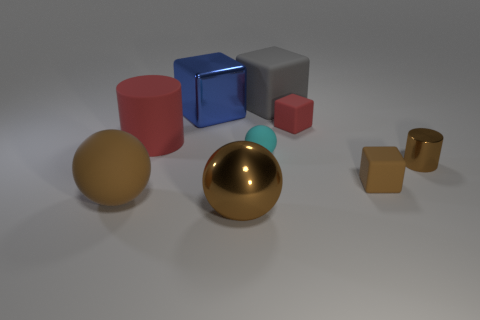There is a sphere that is the same size as the red cube; what is its material?
Ensure brevity in your answer.  Rubber. What number of other things are there of the same material as the cyan object
Your answer should be compact. 5. There is a shiny cylinder; does it have the same size as the matte sphere behind the small brown cylinder?
Make the answer very short. Yes. Is the number of cylinders behind the tiny cyan matte ball less than the number of rubber objects that are in front of the small brown cylinder?
Provide a short and direct response. Yes. There is a brown rubber object on the right side of the red matte cylinder; how big is it?
Offer a very short reply. Small. Is the size of the red cylinder the same as the shiny cube?
Offer a terse response. Yes. How many large things are both in front of the blue thing and on the right side of the cyan thing?
Your answer should be compact. 0. What number of red things are either small rubber blocks or spheres?
Provide a succinct answer. 1. How many matte things are either big blue blocks or tiny red spheres?
Give a very brief answer. 0. Are there any yellow matte spheres?
Your answer should be very brief. No. 